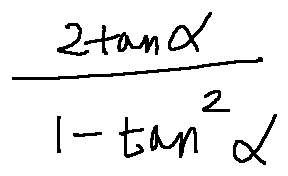Convert formula to latex. <formula><loc_0><loc_0><loc_500><loc_500>\frac { 2 \tan \alpha } { 1 - \tan ^ { 2 } \alpha }</formula> 